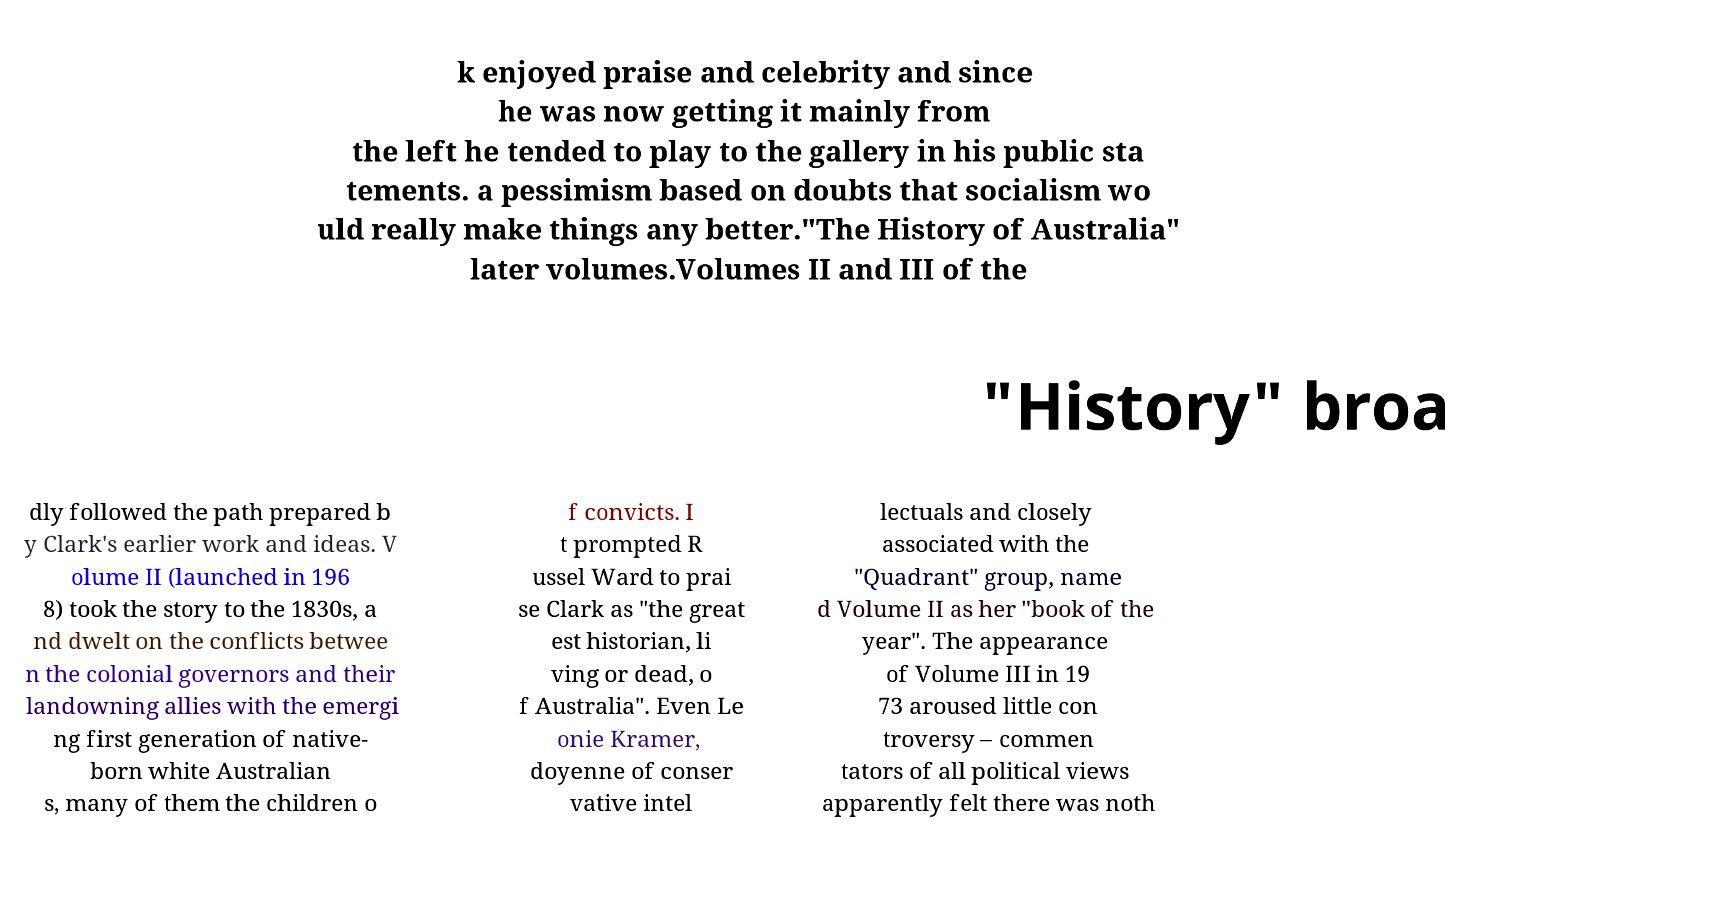Please identify and transcribe the text found in this image. k enjoyed praise and celebrity and since he was now getting it mainly from the left he tended to play to the gallery in his public sta tements. a pessimism based on doubts that socialism wo uld really make things any better."The History of Australia" later volumes.Volumes II and III of the "History" broa dly followed the path prepared b y Clark's earlier work and ideas. V olume II (launched in 196 8) took the story to the 1830s, a nd dwelt on the conflicts betwee n the colonial governors and their landowning allies with the emergi ng first generation of native- born white Australian s, many of them the children o f convicts. I t prompted R ussel Ward to prai se Clark as "the great est historian, li ving or dead, o f Australia". Even Le onie Kramer, doyenne of conser vative intel lectuals and closely associated with the "Quadrant" group, name d Volume II as her "book of the year". The appearance of Volume III in 19 73 aroused little con troversy – commen tators of all political views apparently felt there was noth 